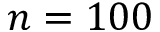<formula> <loc_0><loc_0><loc_500><loc_500>n = 1 0 0</formula> 